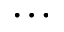<formula> <loc_0><loc_0><loc_500><loc_500>\dots</formula> 